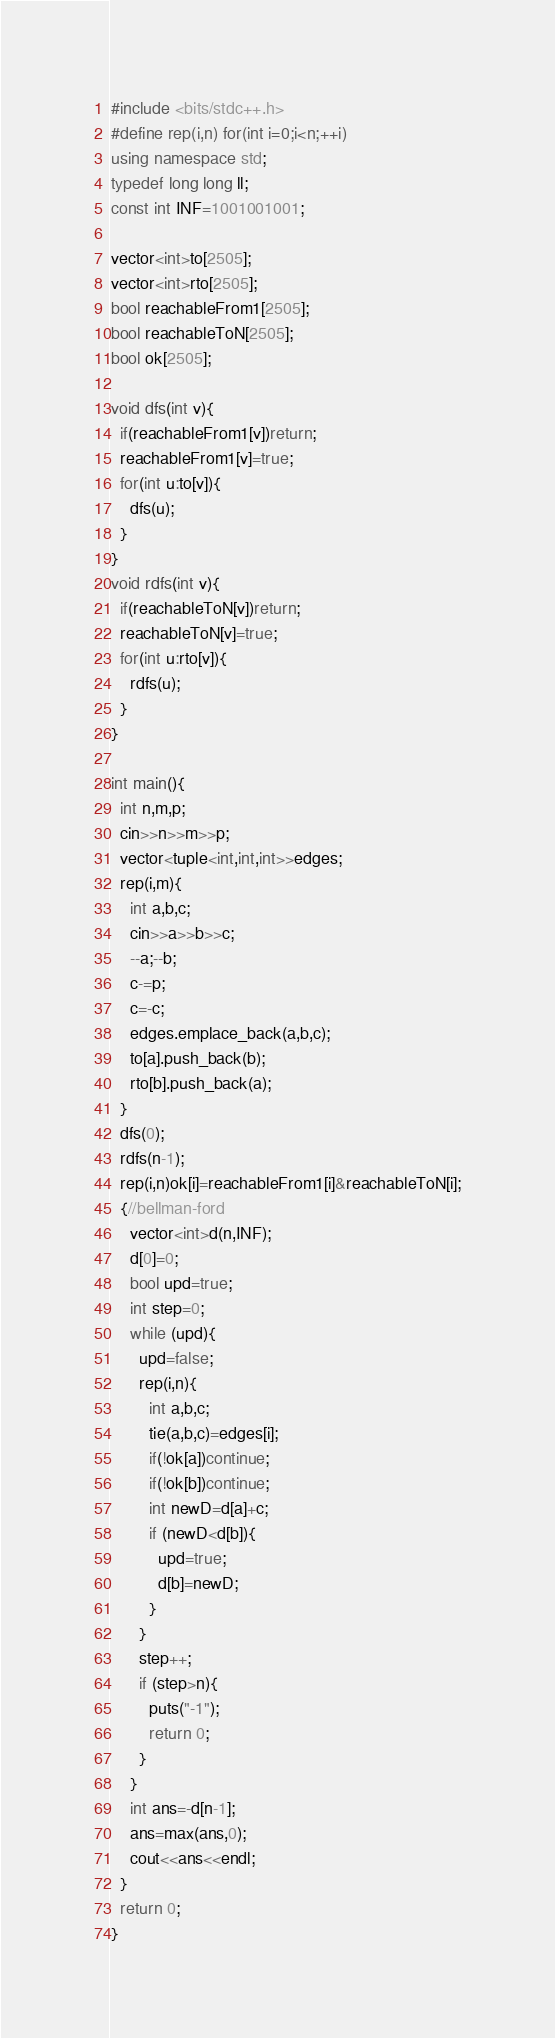<code> <loc_0><loc_0><loc_500><loc_500><_C++_>#include <bits/stdc++.h>
#define rep(i,n) for(int i=0;i<n;++i)
using namespace std;
typedef long long ll;
const int INF=1001001001;

vector<int>to[2505];
vector<int>rto[2505];
bool reachableFrom1[2505];
bool reachableToN[2505];
bool ok[2505];

void dfs(int v){
  if(reachableFrom1[v])return;
  reachableFrom1[v]=true;
  for(int u:to[v]){
    dfs(u);
  }
}
void rdfs(int v){
  if(reachableToN[v])return;
  reachableToN[v]=true;
  for(int u:rto[v]){
    rdfs(u);
  }
}

int main(){
  int n,m,p;
  cin>>n>>m>>p;
  vector<tuple<int,int,int>>edges;
  rep(i,m){
    int a,b,c;
    cin>>a>>b>>c;
    --a;--b;
    c-=p;
    c=-c;
    edges.emplace_back(a,b,c);
    to[a].push_back(b);
    rto[b].push_back(a);
  }
  dfs(0);
  rdfs(n-1);
  rep(i,n)ok[i]=reachableFrom1[i]&reachableToN[i];
  {//bellman-ford
    vector<int>d(n,INF);
    d[0]=0;
    bool upd=true;
    int step=0;
    while (upd){
      upd=false;
      rep(i,n){
        int a,b,c;
        tie(a,b,c)=edges[i];
        if(!ok[a])continue;
        if(!ok[b])continue;
        int newD=d[a]+c;
        if (newD<d[b]){
          upd=true;
          d[b]=newD;
        }
      }
      step++;
      if (step>n){
        puts("-1");
        return 0;
      }
    }
    int ans=-d[n-1];
    ans=max(ans,0);    
    cout<<ans<<endl;
  }
  return 0;
}
</code> 